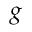<formula> <loc_0><loc_0><loc_500><loc_500>g</formula> 